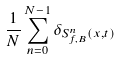Convert formula to latex. <formula><loc_0><loc_0><loc_500><loc_500>\frac { 1 } { N } \sum _ { n = 0 } ^ { N - 1 } \delta _ { S _ { f , B } ^ { n } ( x , t ) }</formula> 